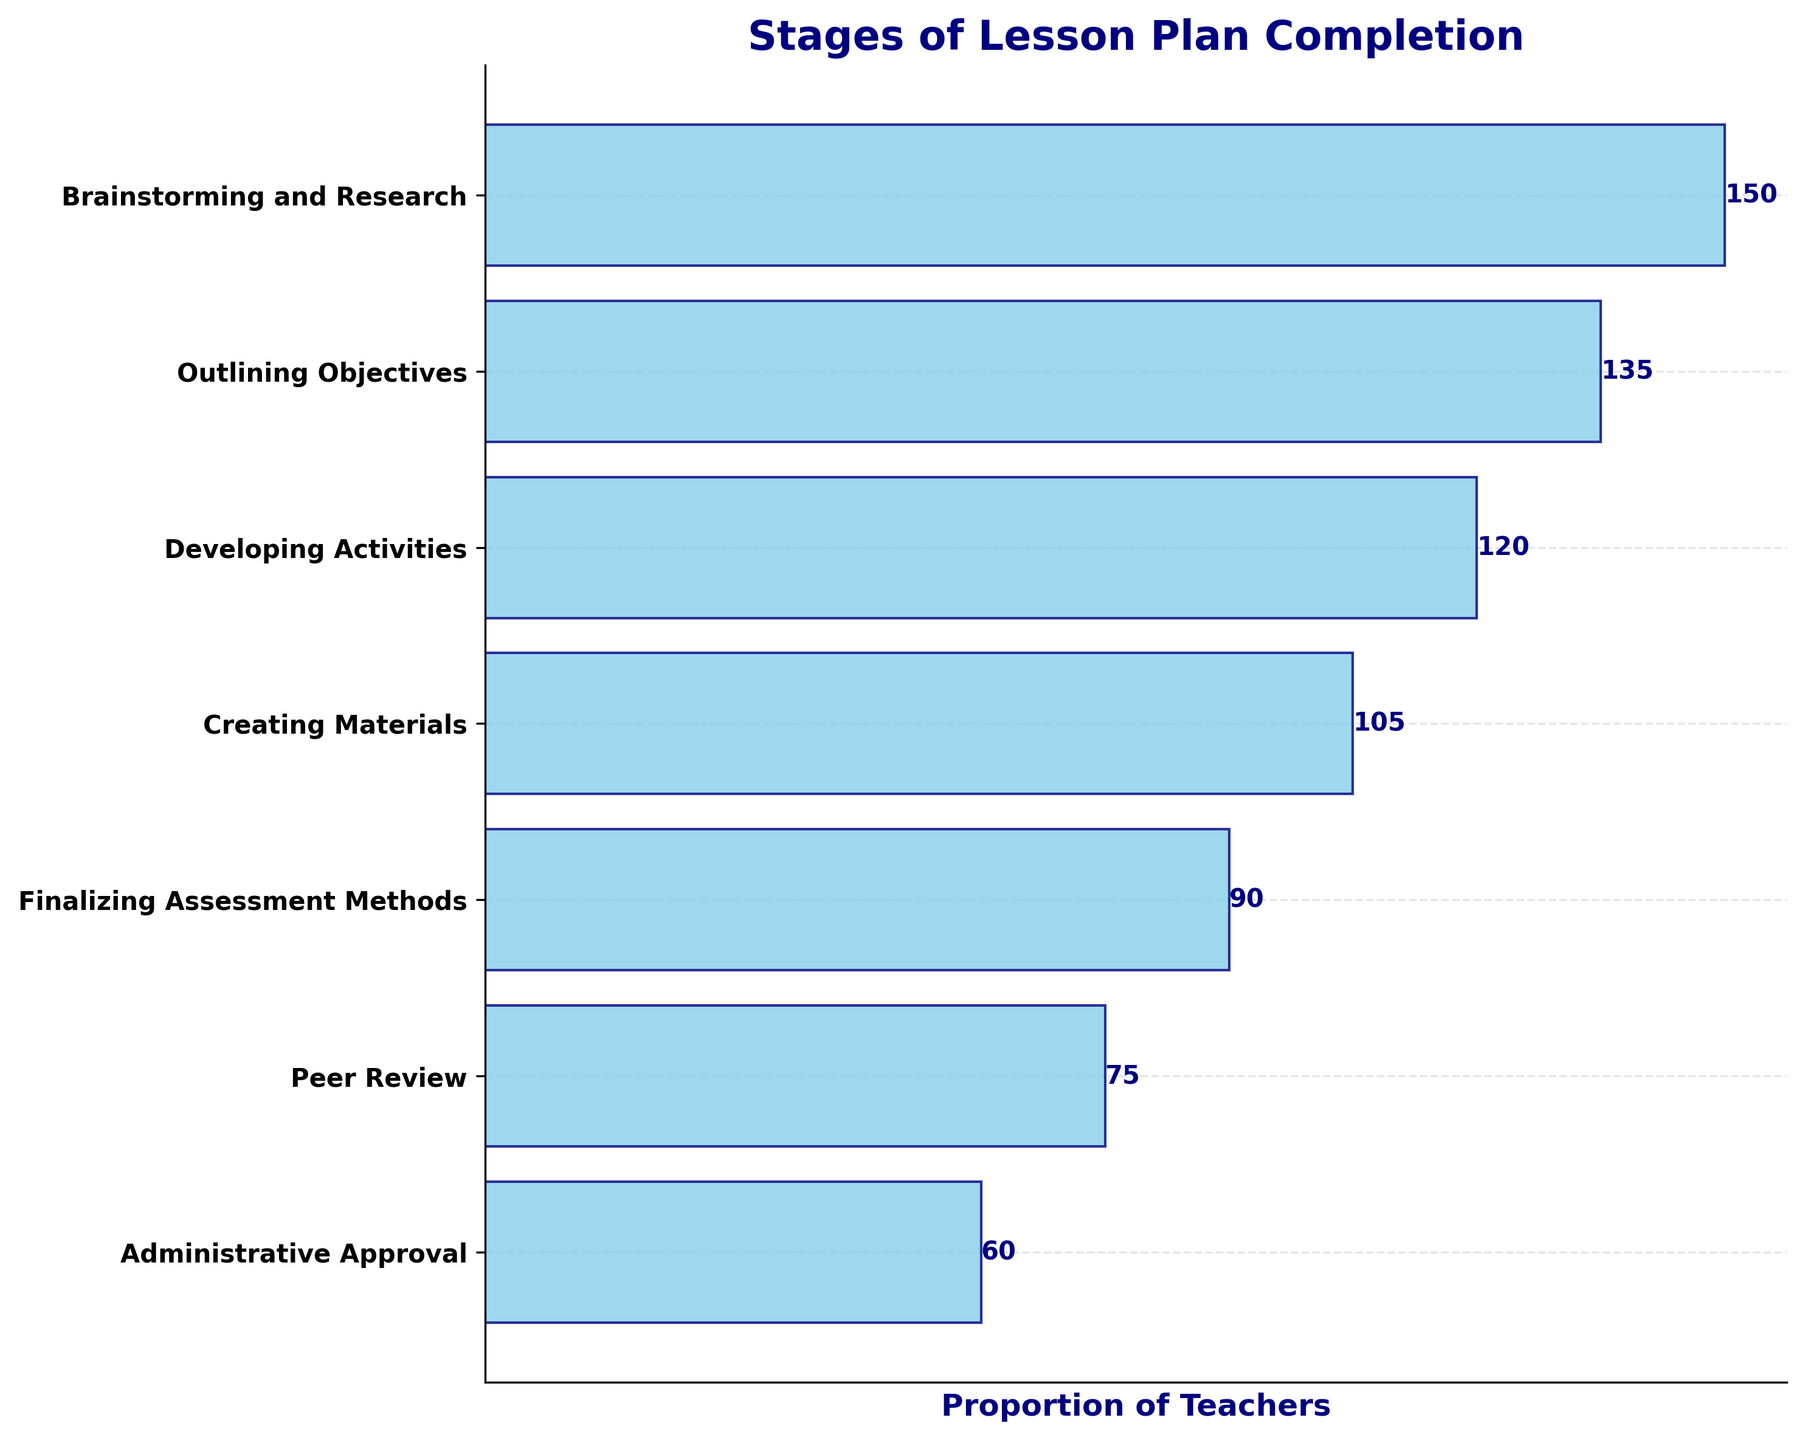What stage has the highest number of teachers? To determine the stage with the highest number of teachers, look for the largest bar in the funnel chart. The stage at the top represents the beginning of the process, and the bar's length corresponds to the number of teachers.
Answer: Brainstorming and Research How many teachers are in the Creating Materials stage? Identify the bar corresponding to the Creating Materials stage and read the number indicated at the end of the bar.
Answer: 105 Which stage has the smallest number of teachers? To find the stage with the smallest number of teachers, look for the shortest bar in the funnel chart. This is usually positioned towards the bottom of the funnel.
Answer: Administrative Approval What is the total number of teachers involved in the stages? Sum the values of teachers for each stage: 150 + 135 + 120 + 105 + 90 + 75 + 60.
Answer: 735 How many more teachers are in the Brainstorming and Research stage than in the Finalizing Assessment Methods stage? Subtract the number of teachers in the Finalizing Assessment Methods stage from the number in the Brainstorming and Research stage: 150 - 90.
Answer: 60 What is the difference in the number of teachers between the Outlining Objectives and the Developing Activities stages? Subtract the number of teachers in the Developing Activities stage from those in the Outlining Objectives stage: 135 - 120.
Answer: 15 How many teachers are in stages from Creating Materials to Administrative Approval combined? Sum the values of teachers for the stages Creating Materials, Finalizing Assessment Methods, Peer Review, and Administrative Approval: 105 + 90 + 75 + 60.
Answer: 330 Which stages have less than 100 teachers? Identify the stages where the number of teachers is less than 100 by looking at the numbers at the end of each bar.
Answer: Peer Review and Administrative Approval By how much does the number of teachers decrease between each subsequent stage of the funnel? Calculate the difference in the number of teachers between each consecutive stage and note the decreasing pattern: (150 - 135), (135 - 120), (120 - 105), (105 - 90), (90 - 75), (75 - 60).
Answer: 15, 15, 15, 15, 15, 15 What percentage of teachers have reached the Administrative Approval stage? Calculate the percentage of teachers in the Administrative Approval stage by dividing the number of teachers at this stage by the total number of teachers in the initial stage, then multiply by 100: (60 / 150) * 100.
Answer: 40% 